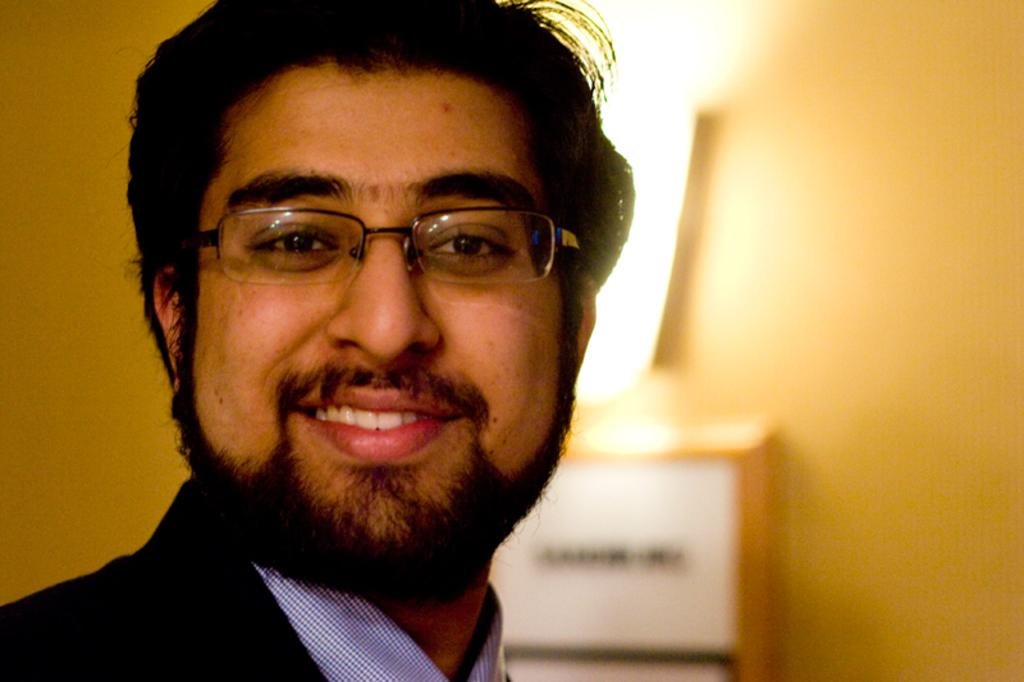What is the main subject of the image? There is a person in the image. What type of clothing is the person wearing? The person is wearing a blazer and a shirt. What accessory is the person wearing? The person is wearing specs. What can be seen in the background of the image? There is a light, an object, and a yellow color wall in the background of the image. How does the person increase the temperature in the image? There is no indication in the image that the person is increasing the temperature. What type of glove is the person wearing in the image? There is no glove present in the image; the person is wearing specs. 